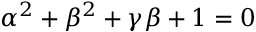<formula> <loc_0><loc_0><loc_500><loc_500>\alpha ^ { 2 } + \beta ^ { 2 } + \gamma \beta + 1 = 0</formula> 